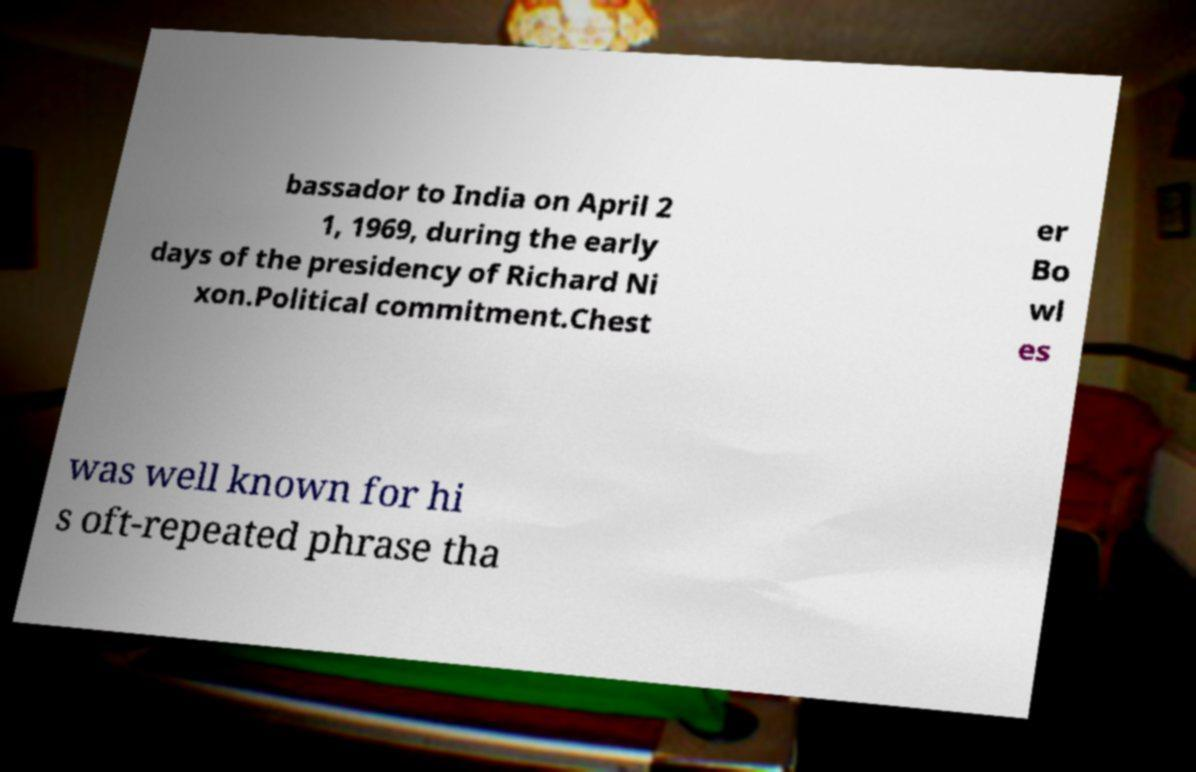Could you assist in decoding the text presented in this image and type it out clearly? bassador to India on April 2 1, 1969, during the early days of the presidency of Richard Ni xon.Political commitment.Chest er Bo wl es was well known for hi s oft-repeated phrase tha 